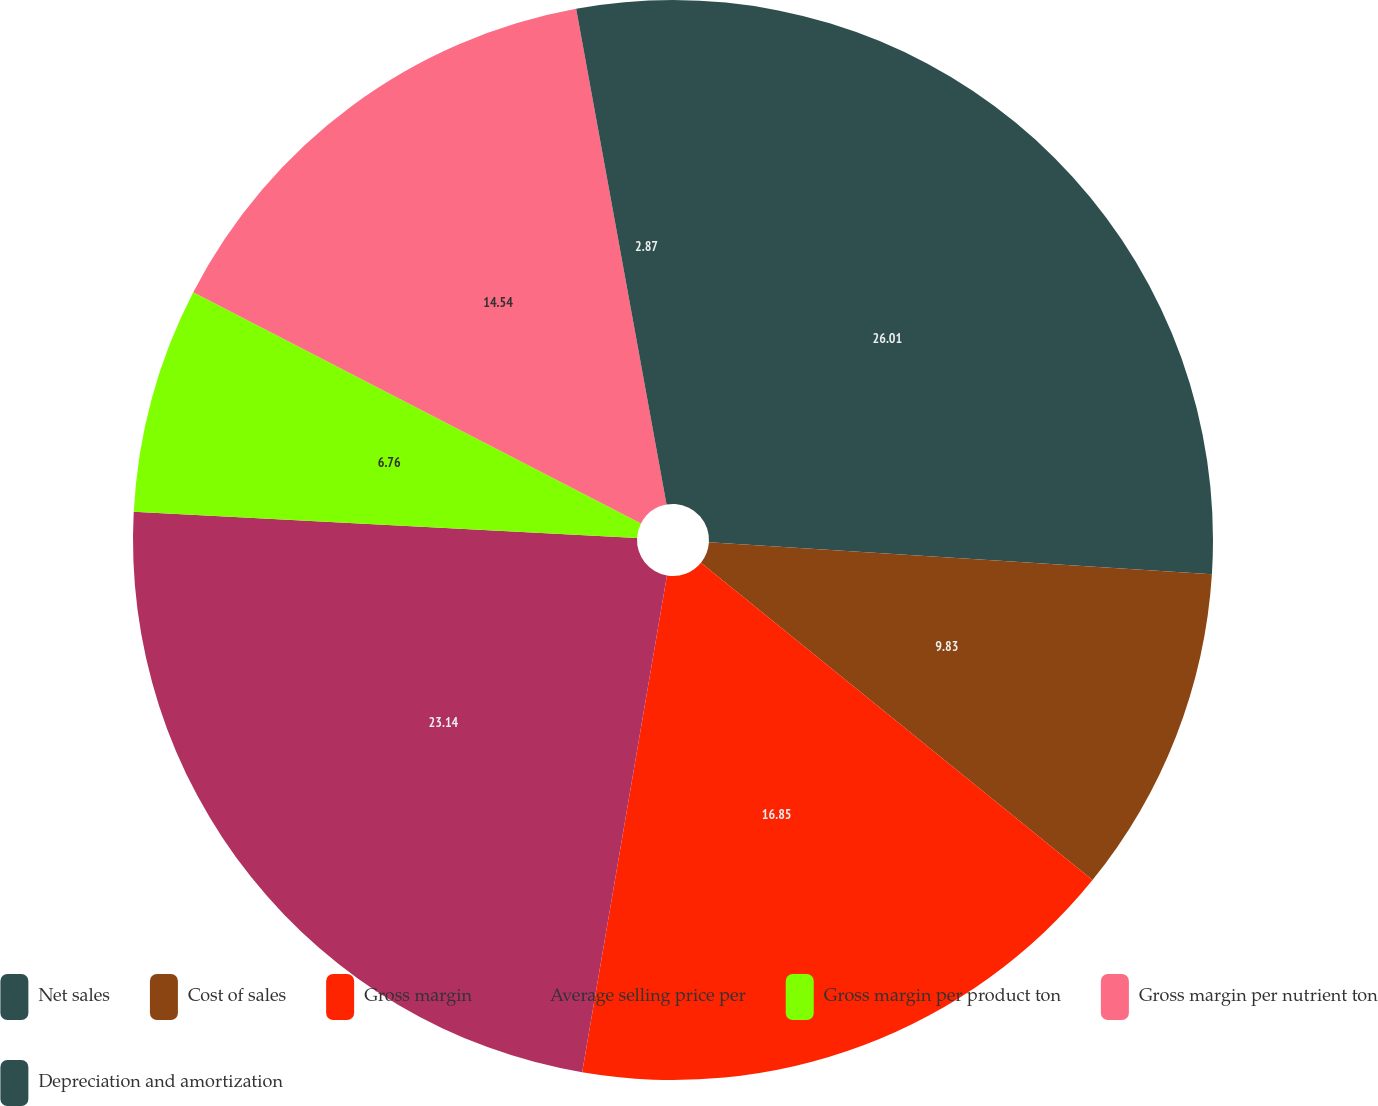Convert chart to OTSL. <chart><loc_0><loc_0><loc_500><loc_500><pie_chart><fcel>Net sales<fcel>Cost of sales<fcel>Gross margin<fcel>Average selling price per<fcel>Gross margin per product ton<fcel>Gross margin per nutrient ton<fcel>Depreciation and amortization<nl><fcel>26.01%<fcel>9.83%<fcel>16.85%<fcel>23.14%<fcel>6.76%<fcel>14.54%<fcel>2.87%<nl></chart> 